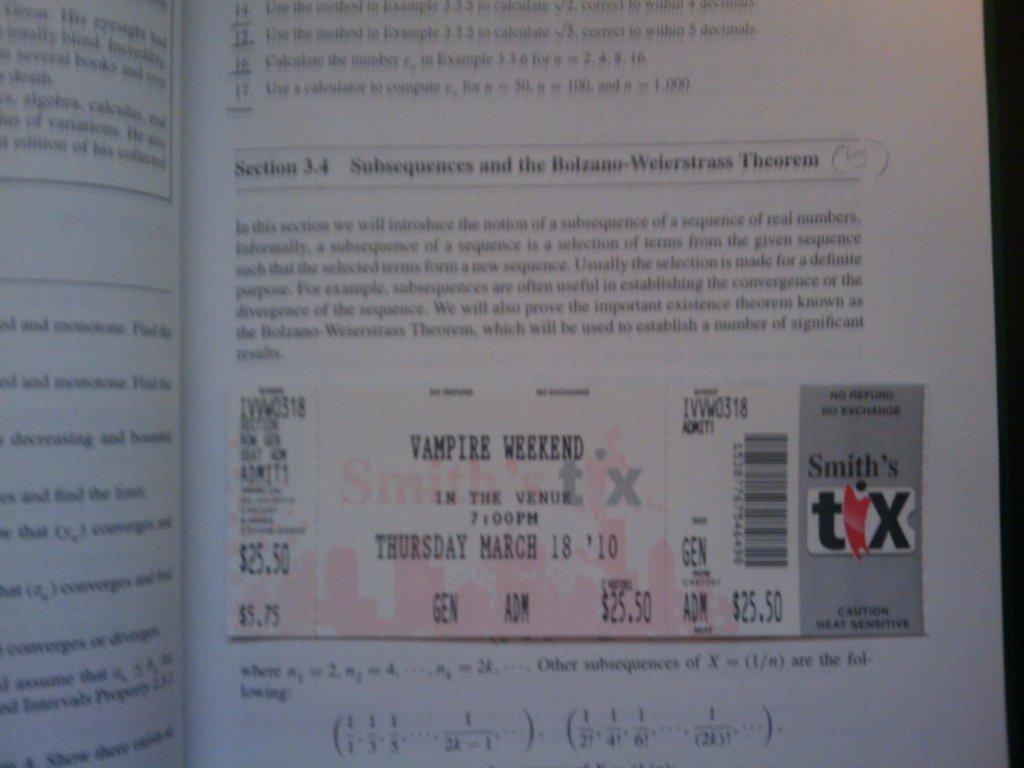<image>
Describe the image concisely. smith's tix movie ticket for vampire weekend laying against open math workbook 